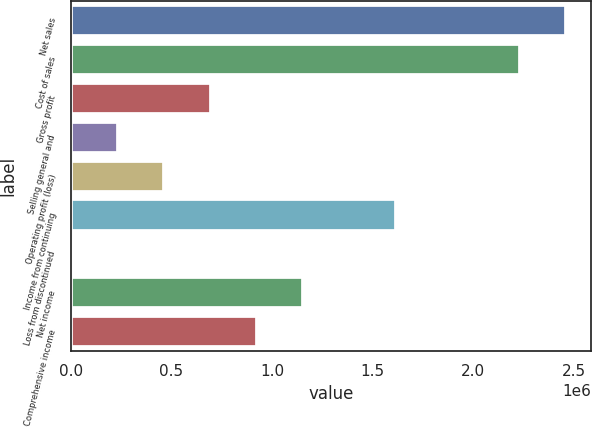<chart> <loc_0><loc_0><loc_500><loc_500><bar_chart><fcel>Net sales<fcel>Cost of sales<fcel>Gross profit<fcel>Selling general and<fcel>Operating profit (loss)<fcel>Income from continuing<fcel>Loss from discontinued<fcel>Net income<fcel>Comprehensive income<nl><fcel>2.4628e+06<fcel>2.23245e+06<fcel>695030<fcel>234333<fcel>464681<fcel>1.61642e+06<fcel>3985<fcel>1.15573e+06<fcel>925378<nl></chart> 